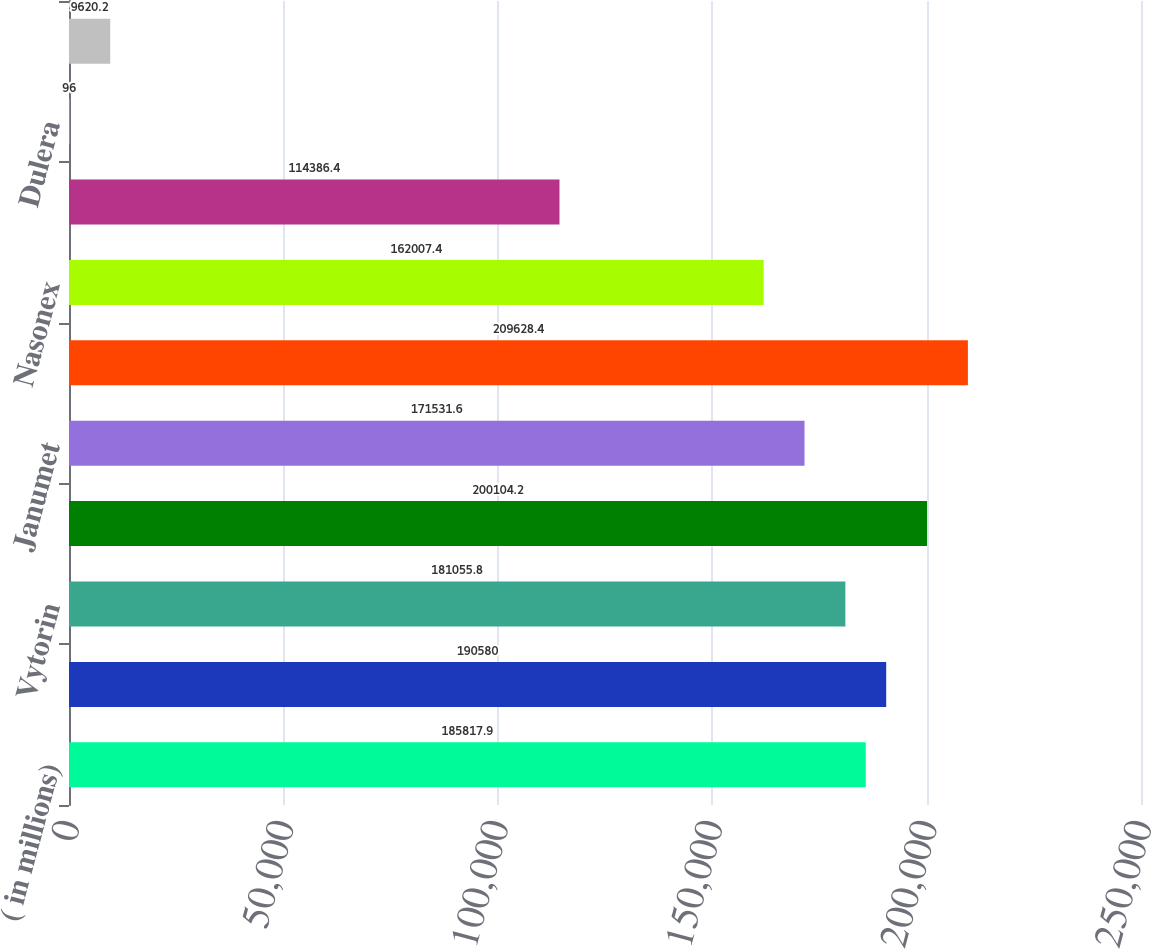<chart> <loc_0><loc_0><loc_500><loc_500><bar_chart><fcel>( in millions)<fcel>Zetia<fcel>Vytorin<fcel>Januvia<fcel>Janumet<fcel>Singulair<fcel>Nasonex<fcel>Clarinex<fcel>Dulera<fcel>Asmanex<nl><fcel>185818<fcel>190580<fcel>181056<fcel>200104<fcel>171532<fcel>209628<fcel>162007<fcel>114386<fcel>96<fcel>9620.2<nl></chart> 